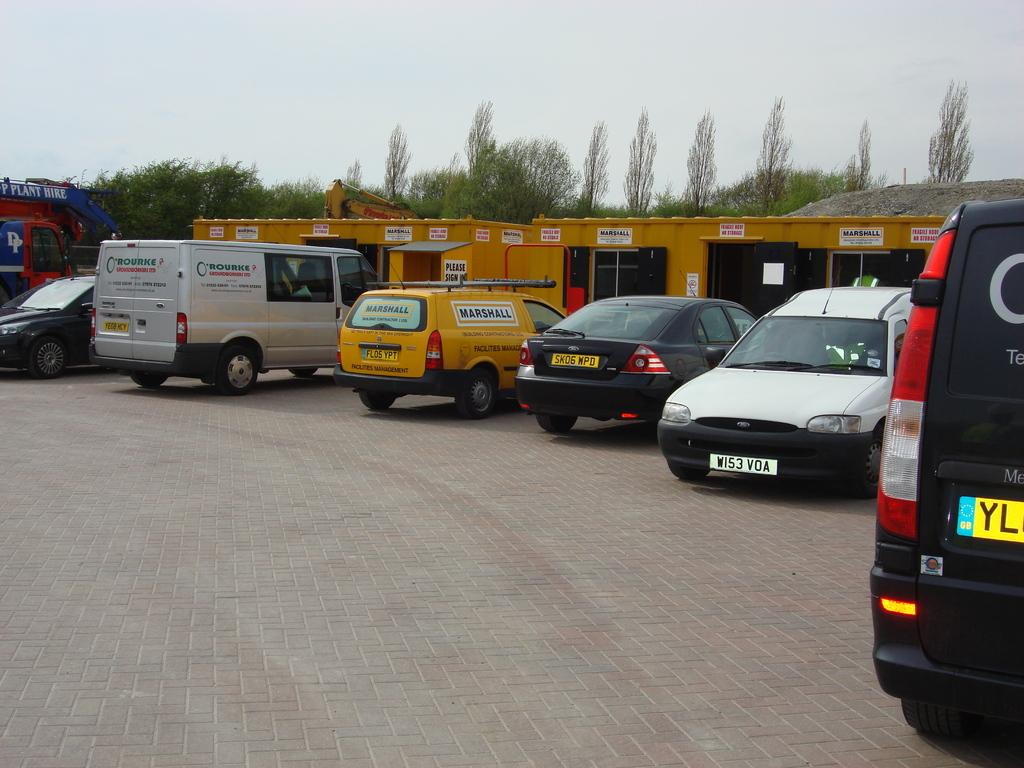<image>
Summarize the visual content of the image. A row of cars are parked in a lot by a white van that says O'Rourke. 